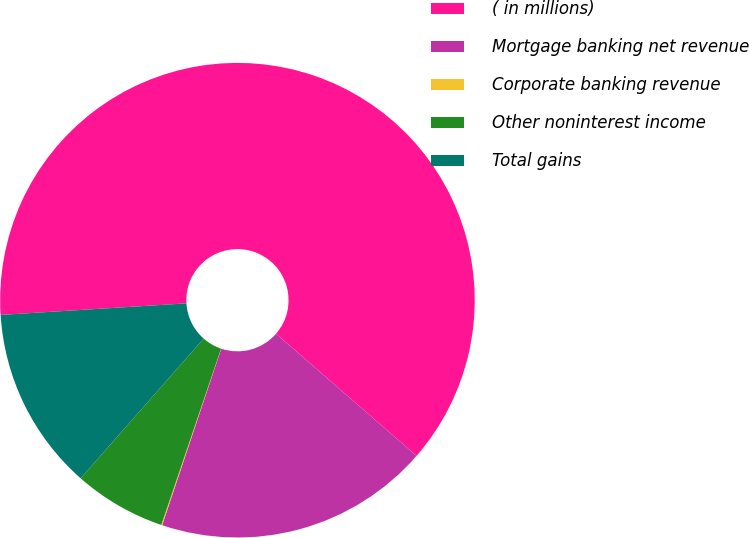Convert chart. <chart><loc_0><loc_0><loc_500><loc_500><pie_chart><fcel>( in millions)<fcel>Mortgage banking net revenue<fcel>Corporate banking revenue<fcel>Other noninterest income<fcel>Total gains<nl><fcel>62.37%<fcel>18.75%<fcel>0.06%<fcel>6.29%<fcel>12.52%<nl></chart> 